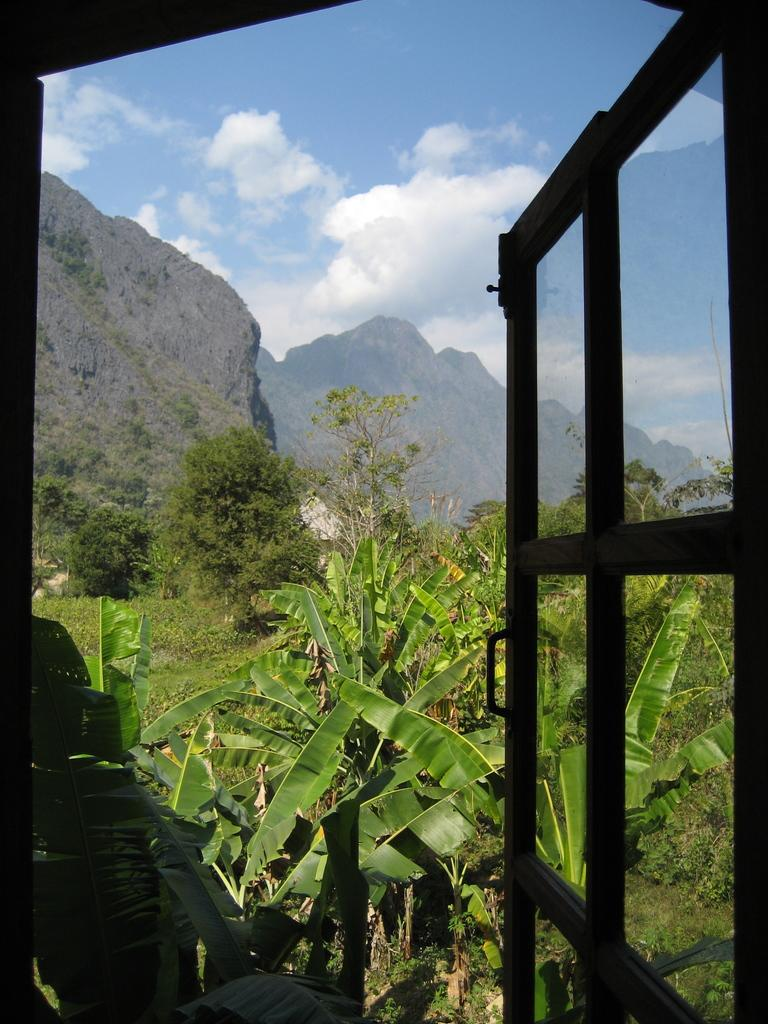What type of natural elements can be seen in the image? There are many trees and plants in the image. What type of landscape feature is visible in the image? There are hills visible in the image. What is the background of the image? There is a sky in the image. Is there any man-made structure present in the image? Yes, there is a door in the image. Can you tell me how many berries are on the chin of the person in the image? There is no person present in the image, and therefore no chin or berries to count. What type of railway can be seen in the image? There is no railway present in the image. 